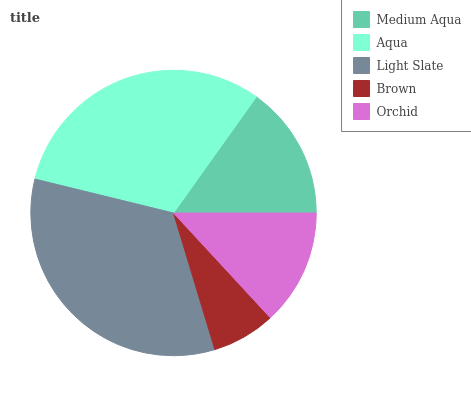Is Brown the minimum?
Answer yes or no. Yes. Is Light Slate the maximum?
Answer yes or no. Yes. Is Aqua the minimum?
Answer yes or no. No. Is Aqua the maximum?
Answer yes or no. No. Is Aqua greater than Medium Aqua?
Answer yes or no. Yes. Is Medium Aqua less than Aqua?
Answer yes or no. Yes. Is Medium Aqua greater than Aqua?
Answer yes or no. No. Is Aqua less than Medium Aqua?
Answer yes or no. No. Is Medium Aqua the high median?
Answer yes or no. Yes. Is Medium Aqua the low median?
Answer yes or no. Yes. Is Light Slate the high median?
Answer yes or no. No. Is Orchid the low median?
Answer yes or no. No. 